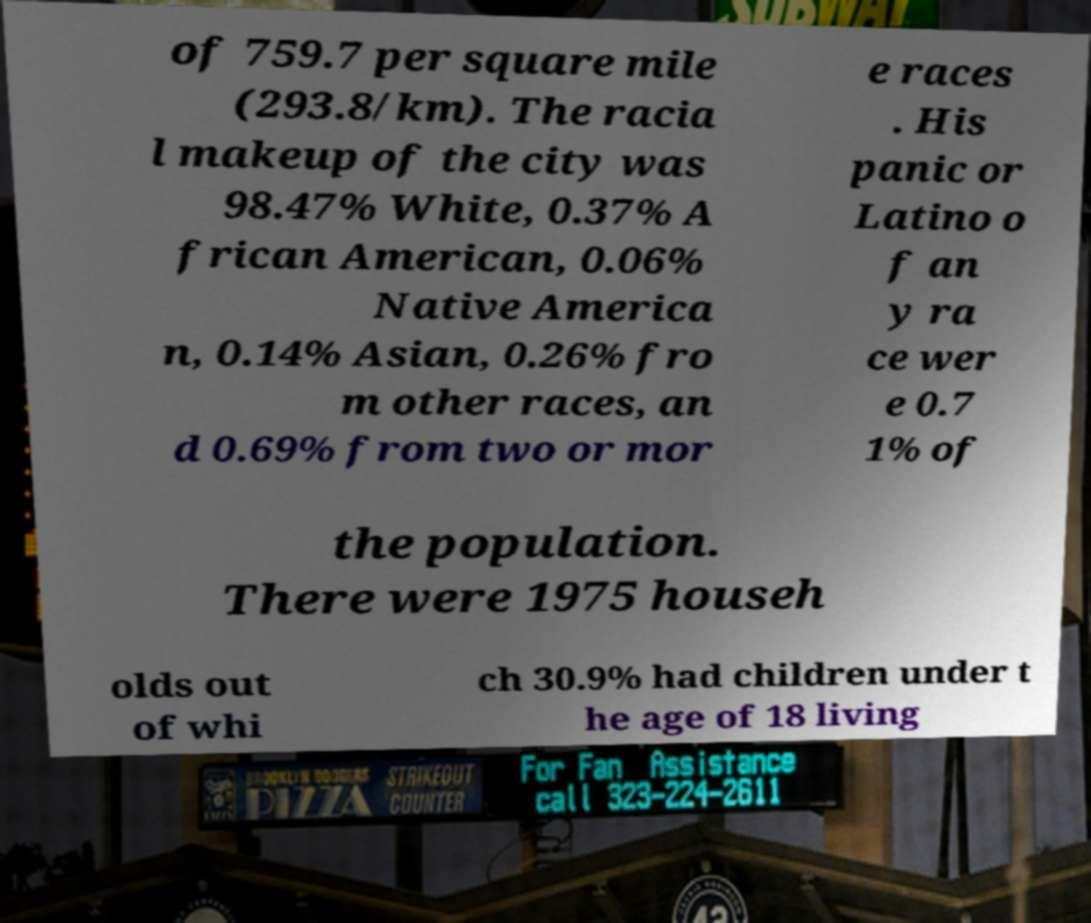Can you accurately transcribe the text from the provided image for me? of 759.7 per square mile (293.8/km). The racia l makeup of the city was 98.47% White, 0.37% A frican American, 0.06% Native America n, 0.14% Asian, 0.26% fro m other races, an d 0.69% from two or mor e races . His panic or Latino o f an y ra ce wer e 0.7 1% of the population. There were 1975 househ olds out of whi ch 30.9% had children under t he age of 18 living 